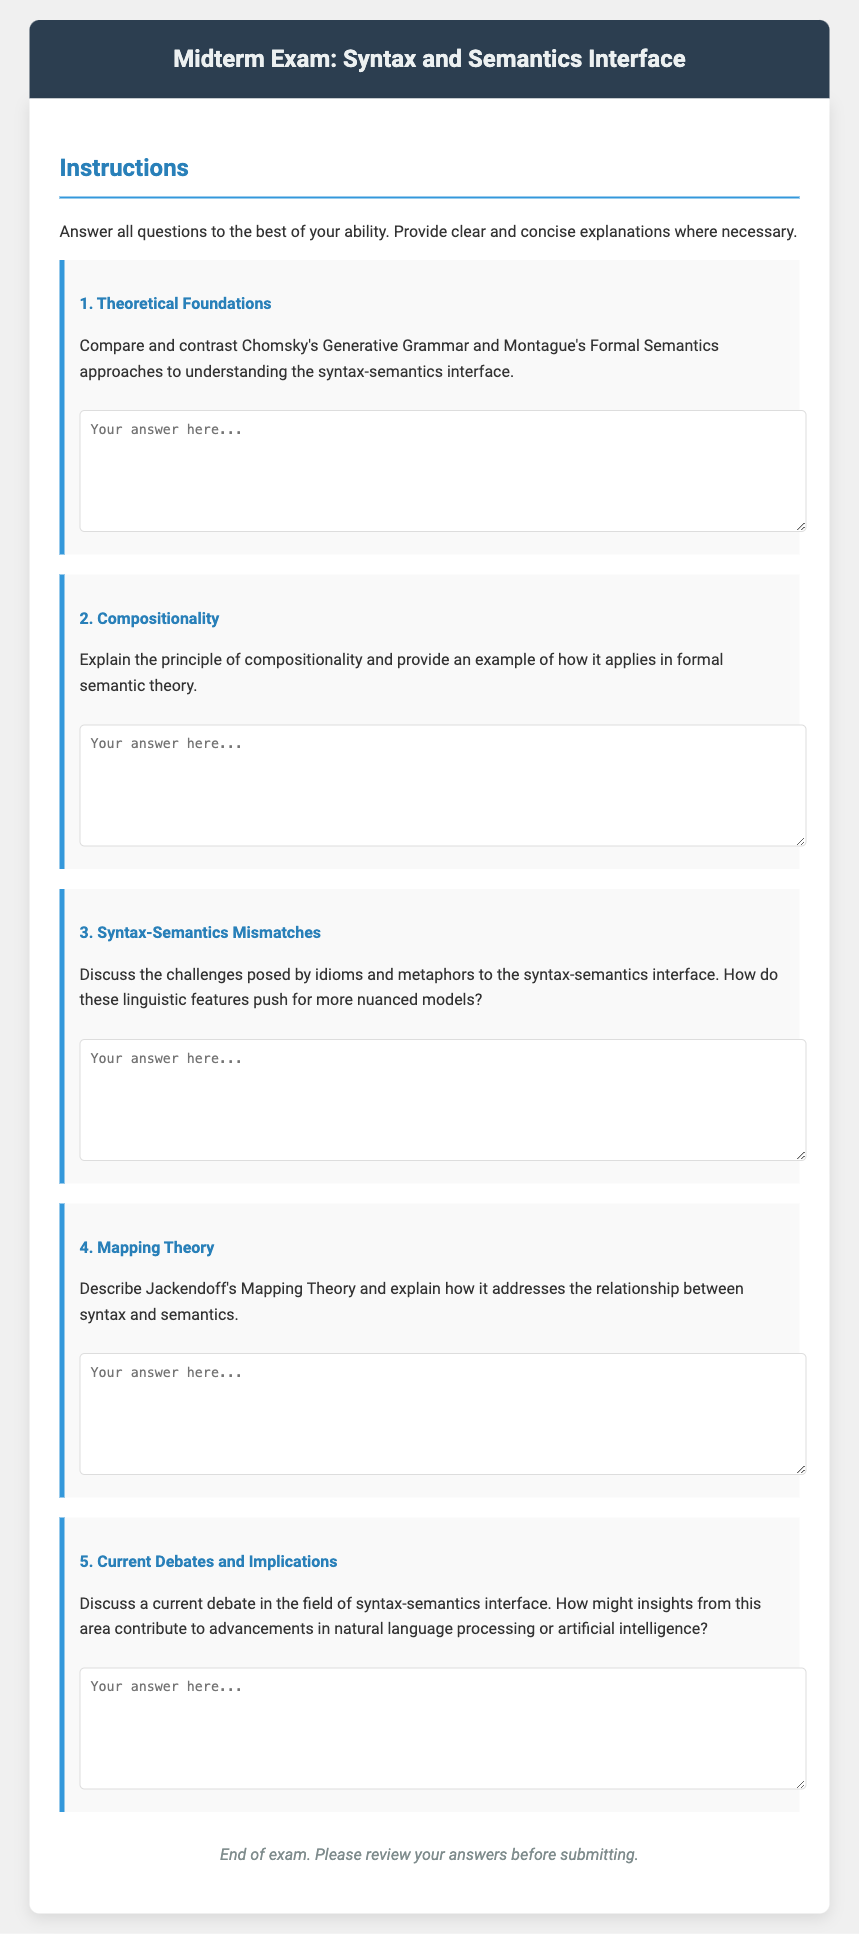What is the title of the exam? The title of the exam is displayed in the exam header section of the document, which reads "Midterm Exam: Syntax and Semantics Interface."
Answer: Midterm Exam: Syntax and Semantics Interface How many questions are in the exam? The number of questions can be counted in the content section of the document, where there are five distinct questions listed.
Answer: 5 What is the main topic of the exam? The main topic is indicated in the title as well as throughout the questions that focus on the syntax and semantics interface.
Answer: Syntax and Semantics Interface What is the color of the exam header? The exam header color is specified in the style section, and it is set to a dark shade #2c3e50.
Answer: #2c3e50 Which theoretical approach is compared with Montague's Formal Semantics in Question 1? Theoretical approaches mentioned are Chomsky's Generative Grammar and Montague's Formal Semantics, and the comparison is specifically requested about Chomsky’s approach.
Answer: Chomsky's Generative Grammar What is the first question about? The first question asks for a comparison of specific linguistic theories related to syntax and semantics.
Answer: Theoretical Foundations What does the exam footer indicate? The exam footer provides instructions for the students to review their answers before submitting the exam.
Answer: Review your answers before submitting What does the instruction section ask students to do? The instruction section specifies that students should answer all questions to the best of their ability, providing clear explanations where necessary.
Answer: Answer all questions to the best of your ability 